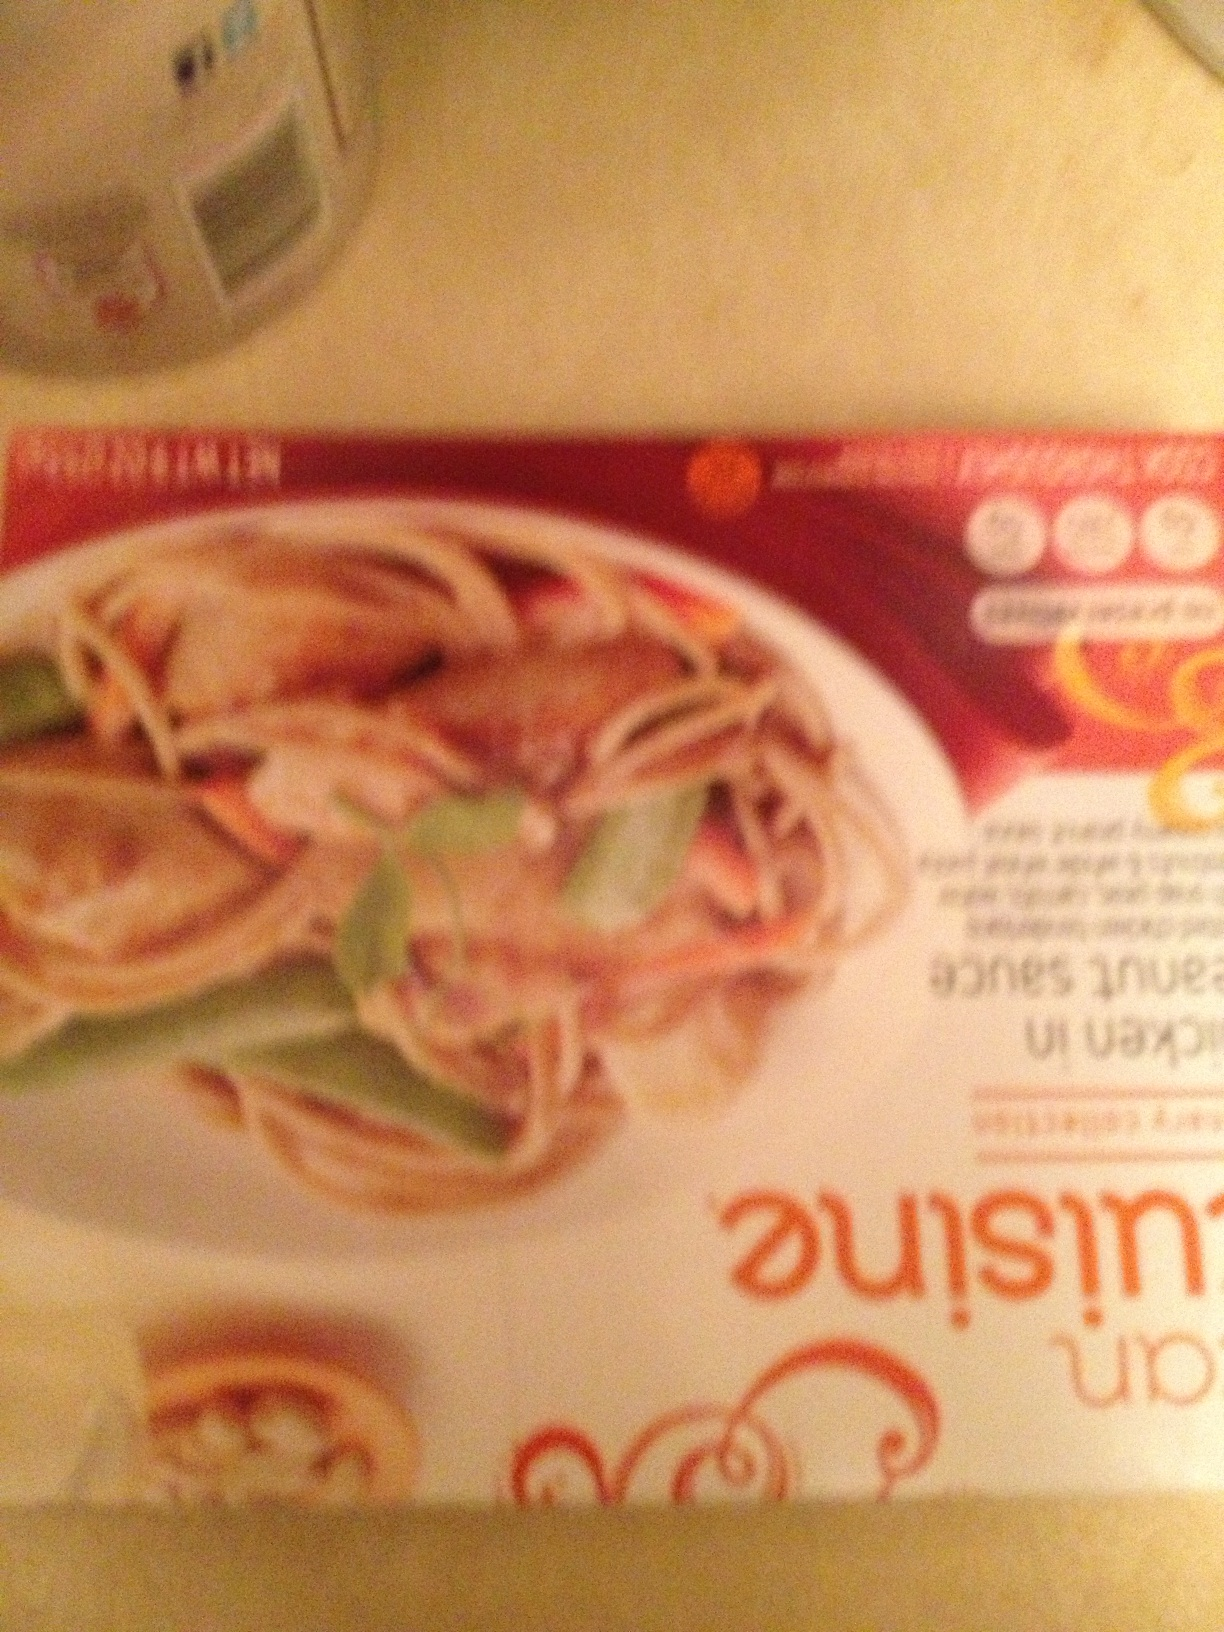Is there any visible text that can help identify the brand or type of cuisine? The image is blurred, making it difficult to read the specific brand or detailed text. However, the style of the package suggests it's likely a type of Asian cuisine. The presence of shrimps and noodles also supports this assumption. 